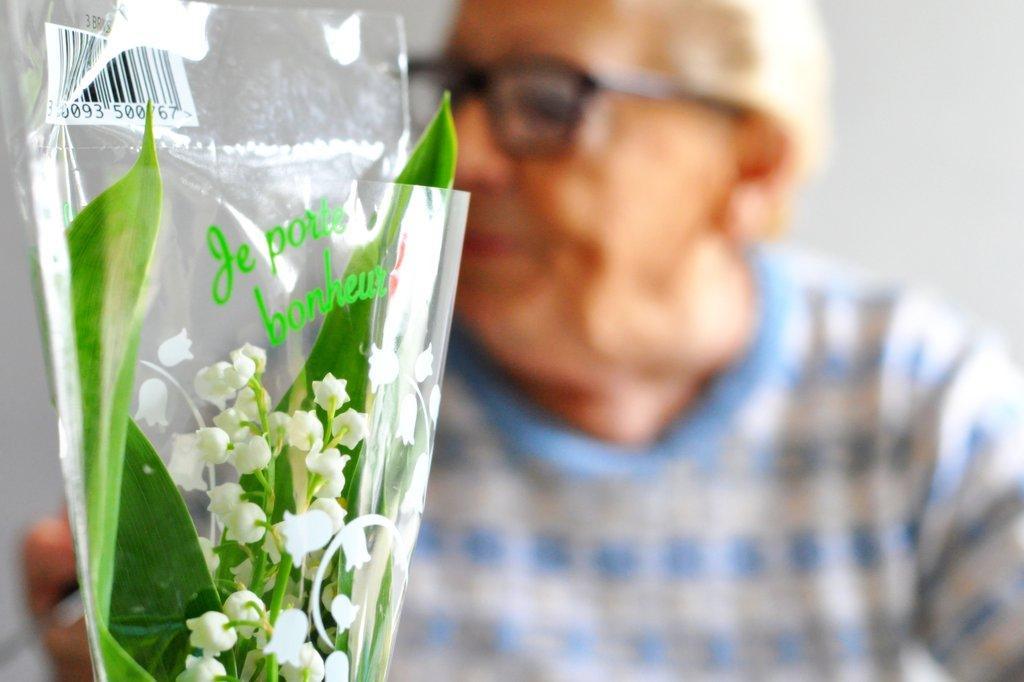Please provide a concise description of this image. In this picture we can see an old man wearing spectacles. Here we can see a flower bouquet in a transparent cover. 